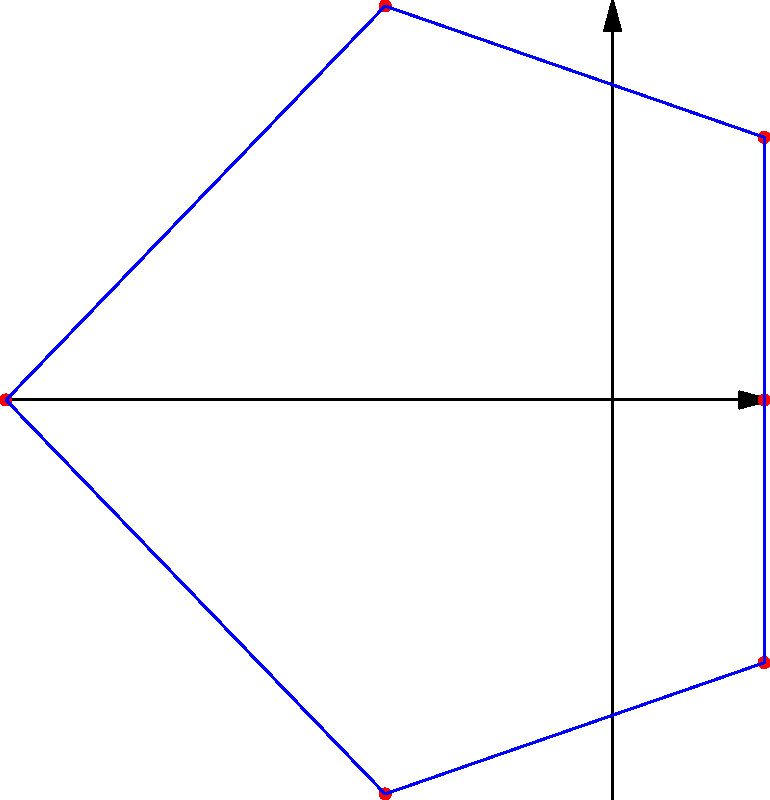A suspect's movements have been tracked and plotted on a polar coordinate system. The suspect's path forms a closed loop, starting and ending at the same point. Given that the suspect moves counterclockwise and the radial distances (in km) and angles (in radians) of the path are:

$$(r, \theta) = \{(1, 0), (2, \frac{\pi}{3}), (3, \frac{2\pi}{3}), (4, \pi), (3, \frac{4\pi}{3}), (2, \frac{5\pi}{3})\}$$

Calculate the total distance traveled by the suspect to the nearest tenth of a kilometer. To calculate the total distance traveled, we need to sum the distances between consecutive points. We'll use the formula for the distance between two points in polar coordinates:

$$d = \sqrt{r_1^2 + r_2^2 - 2r_1r_2\cos(\theta_2 - \theta_1)}$$

Let's calculate the distance between each pair of consecutive points:

1) From $(1, 0)$ to $(2, \frac{\pi}{3})$:
   $$d_1 = \sqrt{1^2 + 2^2 - 2(1)(2)\cos(\frac{\pi}{3} - 0)} = \sqrt{5 - 2\cos(\frac{\pi}{3})} \approx 1.732$$

2) From $(2, \frac{\pi}{3})$ to $(3, \frac{2\pi}{3})$:
   $$d_2 = \sqrt{2^2 + 3^2 - 2(2)(3)\cos(\frac{2\pi}{3} - \frac{\pi}{3})} = \sqrt{13 - 12\cos(\frac{\pi}{3})} \approx 1.732$$

3) From $(3, \frac{2\pi}{3})$ to $(4, \pi)$:
   $$d_3 = \sqrt{3^2 + 4^2 - 2(3)(4)\cos(\pi - \frac{2\pi}{3})} = \sqrt{25 - 24\cos(\frac{\pi}{3})} \approx 1.732$$

4) From $(4, \pi)$ to $(3, \frac{4\pi}{3})$:
   $$d_4 = \sqrt{4^2 + 3^2 - 2(4)(3)\cos(\frac{4\pi}{3} - \pi)} = \sqrt{25 - 24\cos(\frac{\pi}{3})} \approx 1.732$$

5) From $(3, \frac{4\pi}{3})$ to $(2, \frac{5\pi}{3})$:
   $$d_5 = \sqrt{3^2 + 2^2 - 2(3)(2)\cos(\frac{5\pi}{3} - \frac{4\pi}{3})} = \sqrt{13 - 12\cos(\frac{\pi}{3})} \approx 1.732$$

6) From $(2, \frac{5\pi}{3})$ back to $(1, 0)$ (or $2\pi$):
   $$d_6 = \sqrt{2^2 + 1^2 - 2(2)(1)\cos(2\pi - \frac{5\pi}{3})} = \sqrt{5 - 2\cos(\frac{\pi}{3})} \approx 1.732$$

The total distance is the sum of these six distances:
$$\text{Total distance} = d_1 + d_2 + d_3 + d_4 + d_5 + d_6 \approx 6 \times 1.732 = 10.392 \text{ km}$$

Rounding to the nearest tenth, we get 10.4 km.
Answer: 10.4 km 